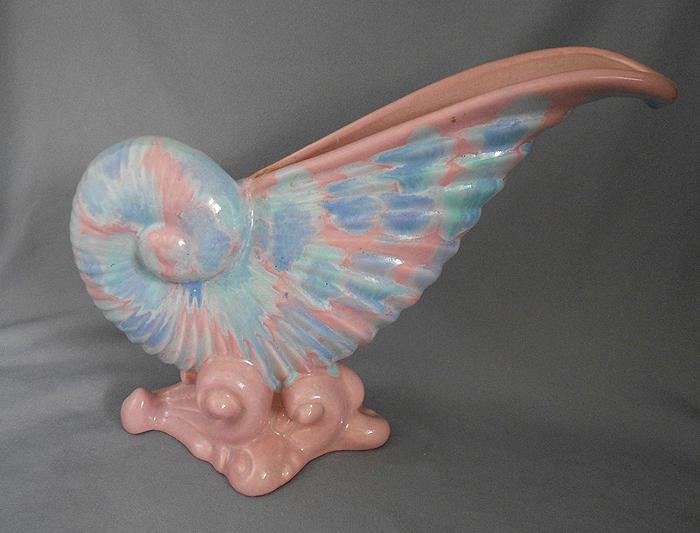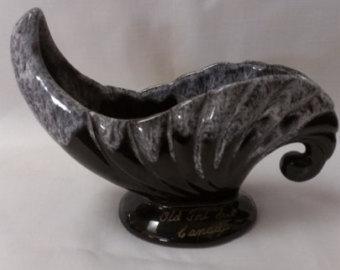The first image is the image on the left, the second image is the image on the right. Analyze the images presented: Is the assertion "An image shows a matched pair of white vases." valid? Answer yes or no. No. The first image is the image on the left, the second image is the image on the right. Assess this claim about the two images: "Two vases in one image are a matched set, while a single vase in the second image is solid white on an oval base.". Correct or not? Answer yes or no. No. 